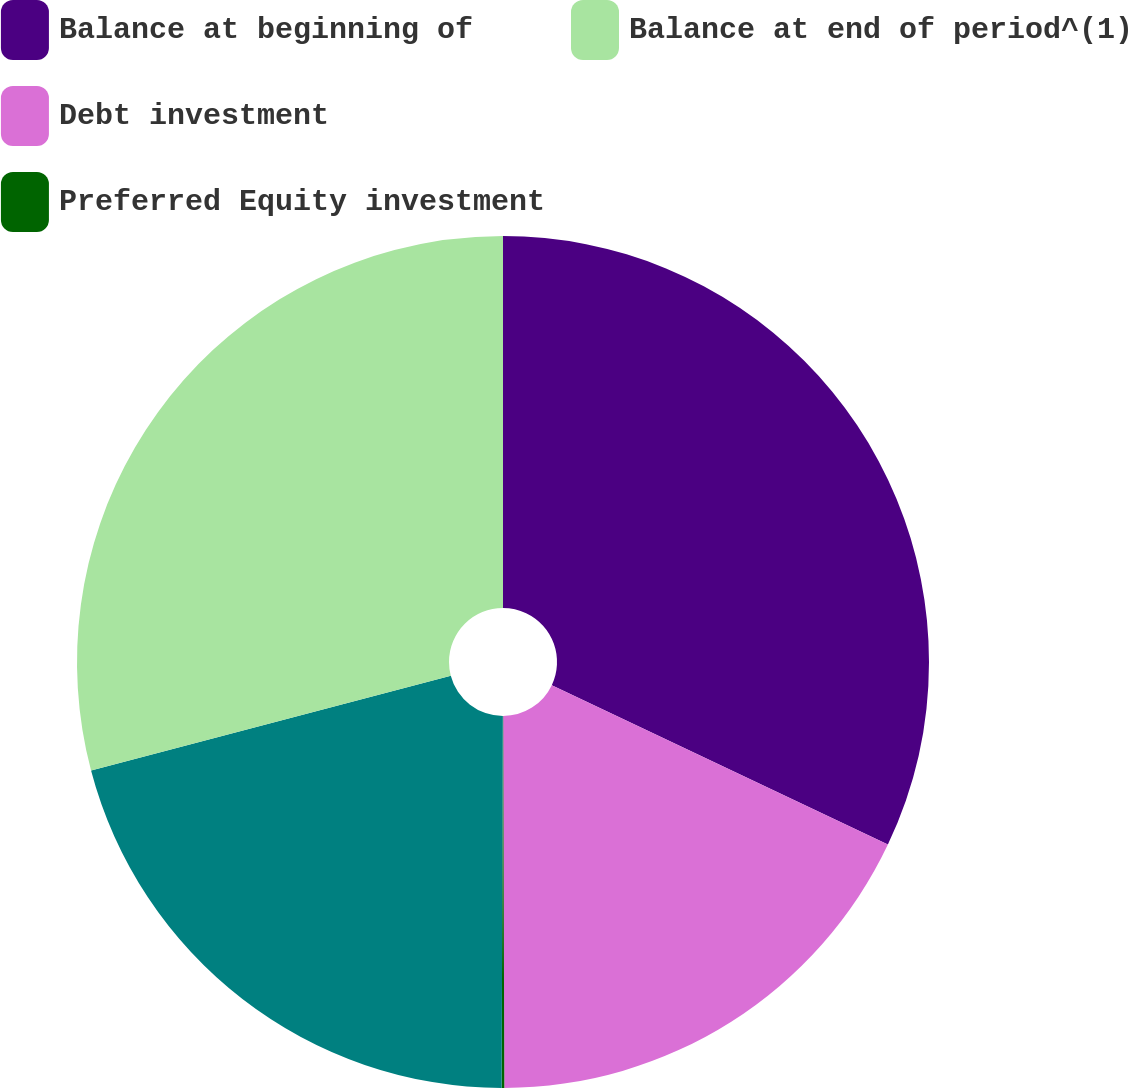Convert chart. <chart><loc_0><loc_0><loc_500><loc_500><pie_chart><fcel>Balance at beginning of<fcel>Debt investment<fcel>Preferred Equity investment<fcel>Unnamed: 3<fcel>Balance at end of period^(1)<nl><fcel>32.05%<fcel>17.9%<fcel>0.1%<fcel>20.85%<fcel>29.1%<nl></chart> 